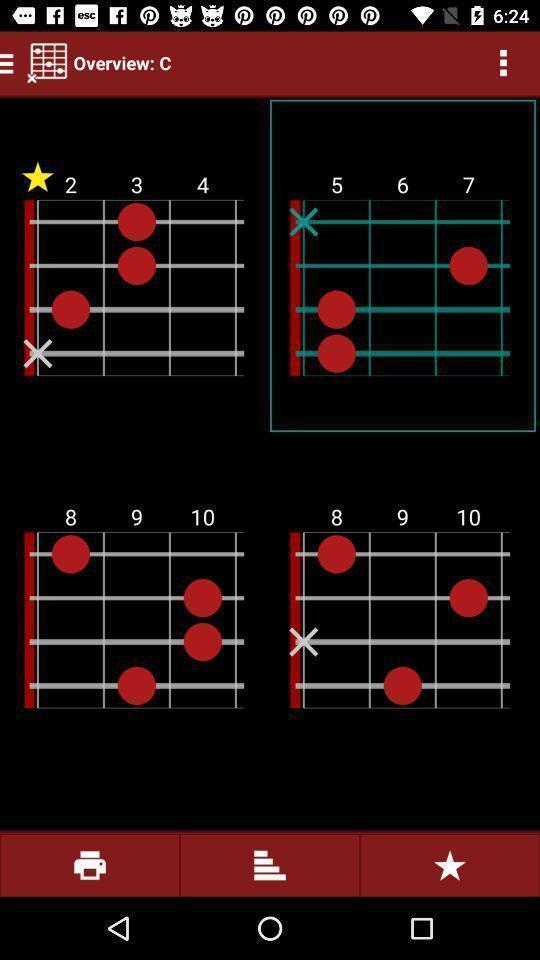What is the overall content of this screenshot? Screen page of a music application. 